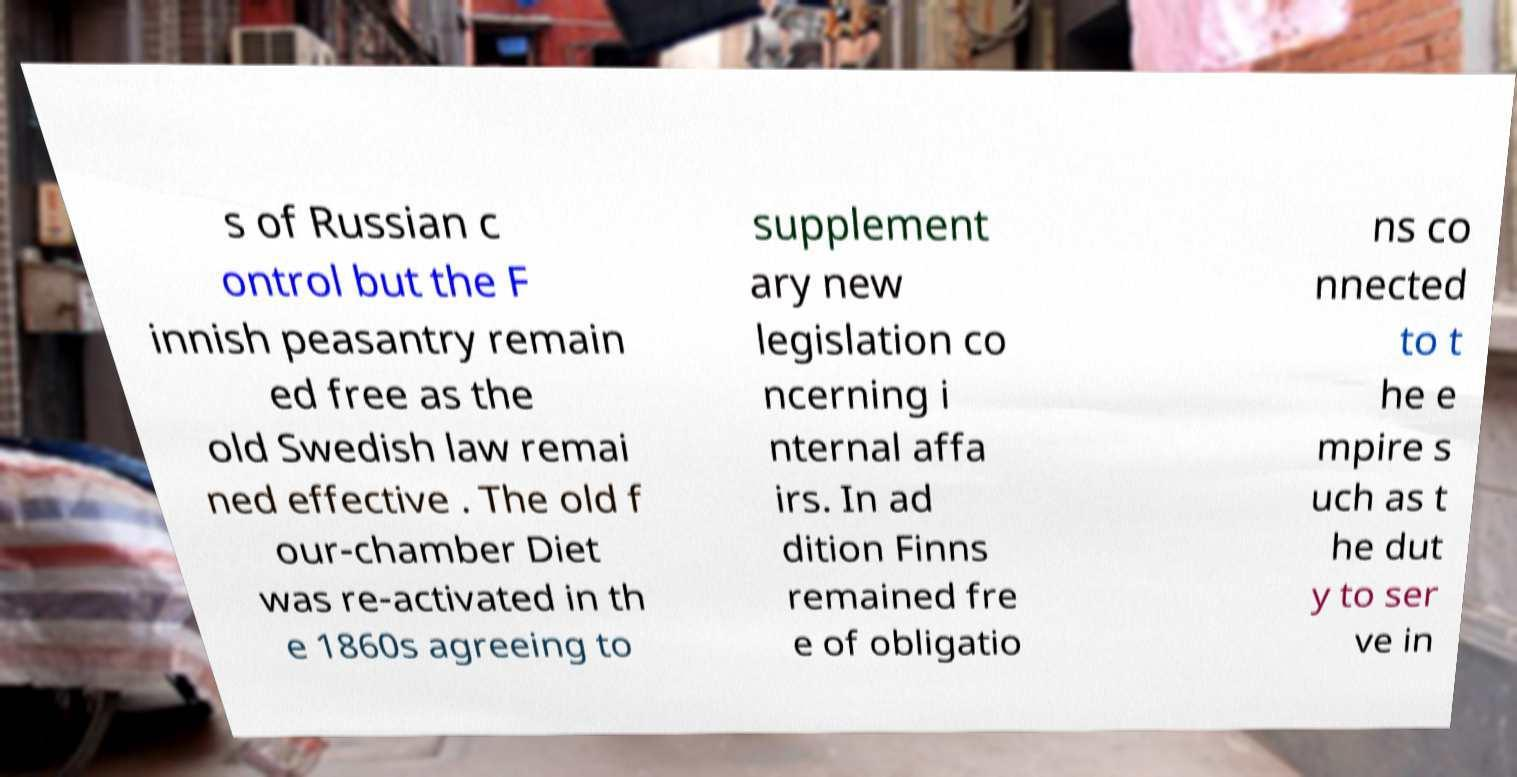I need the written content from this picture converted into text. Can you do that? s of Russian c ontrol but the F innish peasantry remain ed free as the old Swedish law remai ned effective . The old f our-chamber Diet was re-activated in th e 1860s agreeing to supplement ary new legislation co ncerning i nternal affa irs. In ad dition Finns remained fre e of obligatio ns co nnected to t he e mpire s uch as t he dut y to ser ve in 